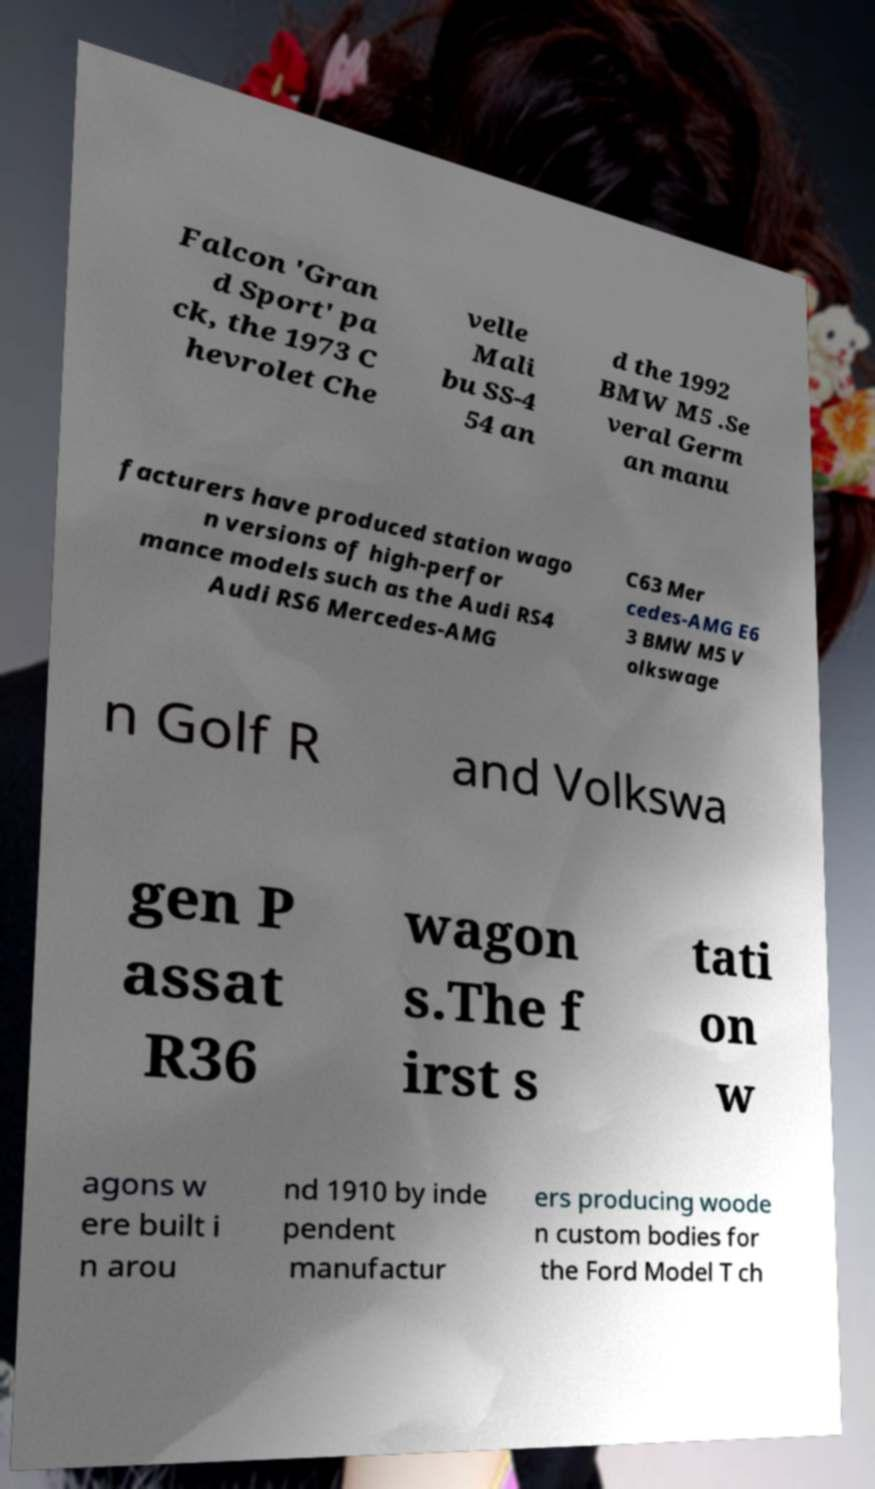What messages or text are displayed in this image? I need them in a readable, typed format. Falcon 'Gran d Sport' pa ck, the 1973 C hevrolet Che velle Mali bu SS-4 54 an d the 1992 BMW M5 .Se veral Germ an manu facturers have produced station wago n versions of high-perfor mance models such as the Audi RS4 Audi RS6 Mercedes-AMG C63 Mer cedes-AMG E6 3 BMW M5 V olkswage n Golf R and Volkswa gen P assat R36 wagon s.The f irst s tati on w agons w ere built i n arou nd 1910 by inde pendent manufactur ers producing woode n custom bodies for the Ford Model T ch 